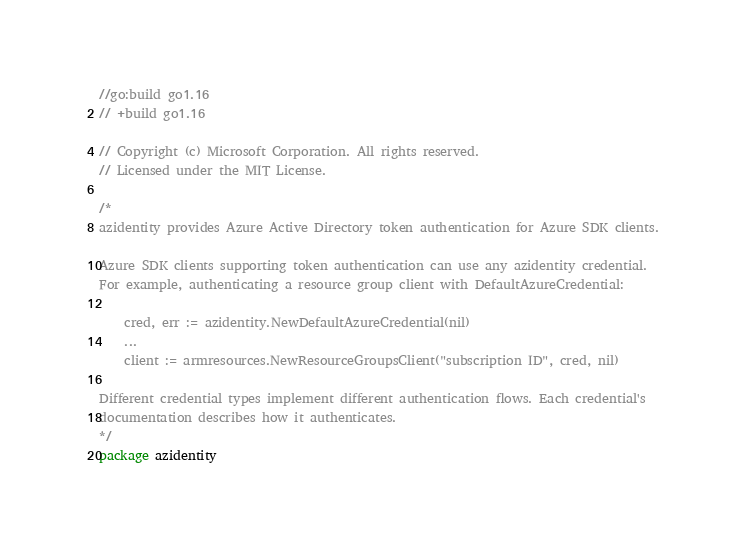<code> <loc_0><loc_0><loc_500><loc_500><_Go_>//go:build go1.16
// +build go1.16

// Copyright (c) Microsoft Corporation. All rights reserved.
// Licensed under the MIT License.

/*
azidentity provides Azure Active Directory token authentication for Azure SDK clients.

Azure SDK clients supporting token authentication can use any azidentity credential.
For example, authenticating a resource group client with DefaultAzureCredential:

	cred, err := azidentity.NewDefaultAzureCredential(nil)
	...
	client := armresources.NewResourceGroupsClient("subscription ID", cred, nil)

Different credential types implement different authentication flows. Each credential's
documentation describes how it authenticates.
*/
package azidentity
</code> 